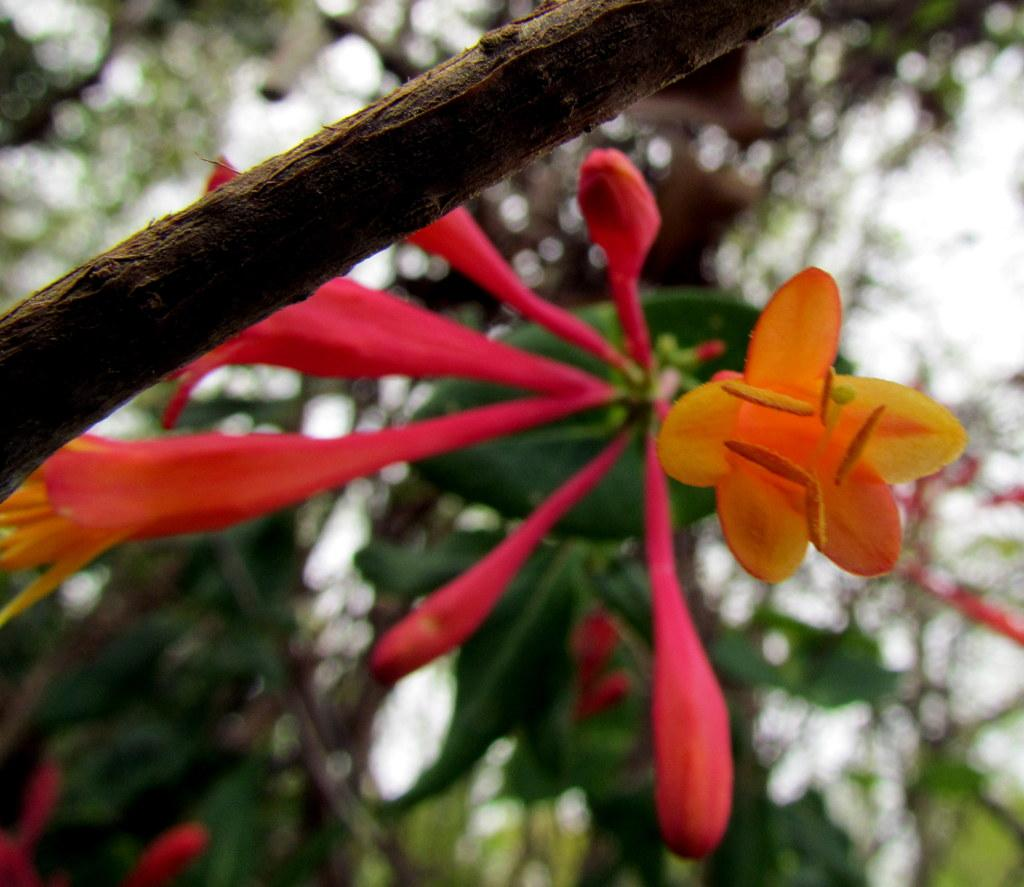What type of plants can be seen in the image? There are flowers in the image. What colors are the flowers? The flowers are red and orange in color. What else is present in the image besides the flowers? There is a branch in the image. How would you describe the background of the image? The background of the image is blurred. How does the beggar interact with the flowers in the image? There is no beggar present in the image, so it is not possible to answer that question. 